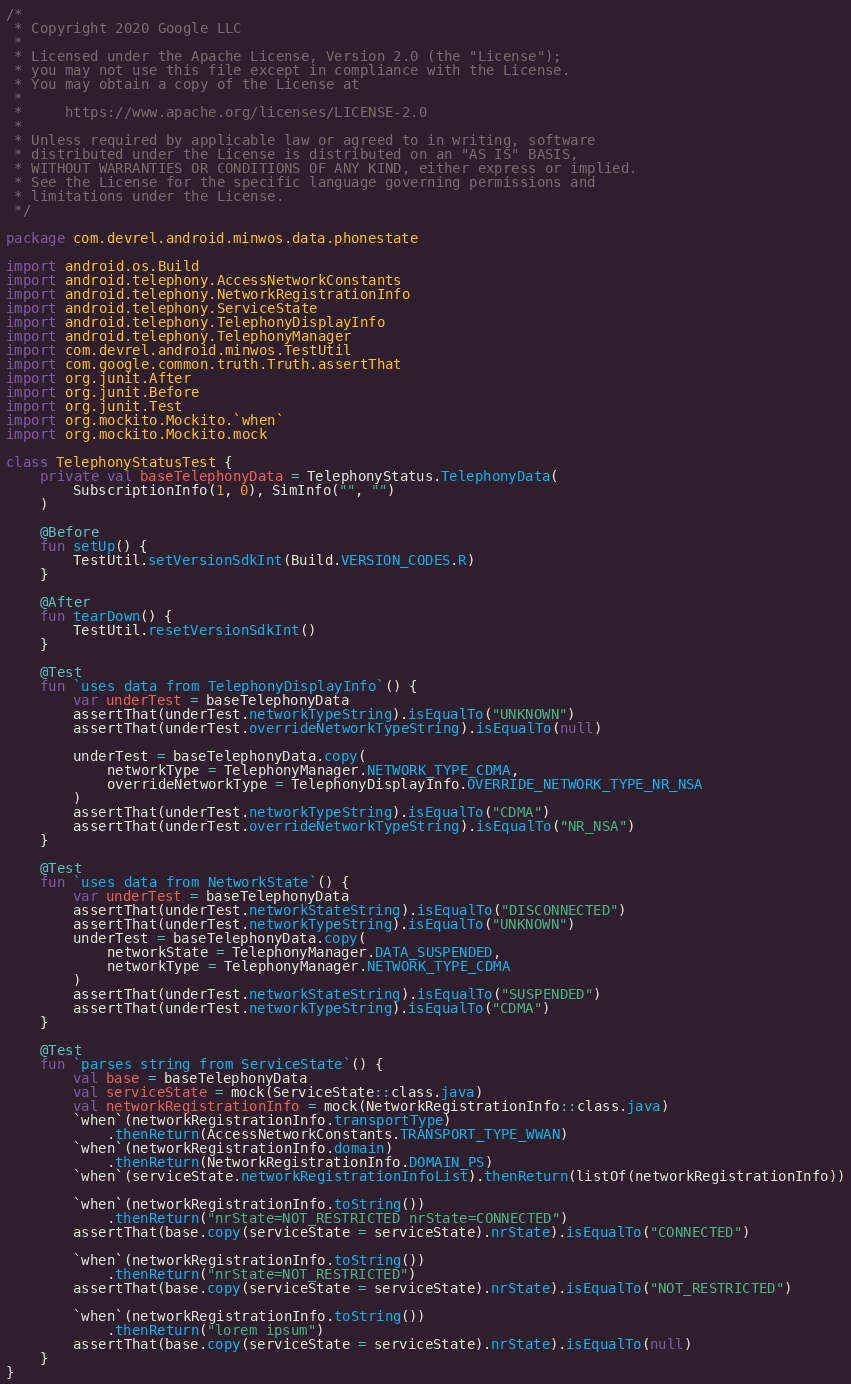<code> <loc_0><loc_0><loc_500><loc_500><_Kotlin_>/*
 * Copyright 2020 Google LLC
 *
 * Licensed under the Apache License, Version 2.0 (the "License");
 * you may not use this file except in compliance with the License.
 * You may obtain a copy of the License at
 *
 *     https://www.apache.org/licenses/LICENSE-2.0
 *
 * Unless required by applicable law or agreed to in writing, software
 * distributed under the License is distributed on an "AS IS" BASIS,
 * WITHOUT WARRANTIES OR CONDITIONS OF ANY KIND, either express or implied.
 * See the License for the specific language governing permissions and
 * limitations under the License.
 */

package com.devrel.android.minwos.data.phonestate

import android.os.Build
import android.telephony.AccessNetworkConstants
import android.telephony.NetworkRegistrationInfo
import android.telephony.ServiceState
import android.telephony.TelephonyDisplayInfo
import android.telephony.TelephonyManager
import com.devrel.android.minwos.TestUtil
import com.google.common.truth.Truth.assertThat
import org.junit.After
import org.junit.Before
import org.junit.Test
import org.mockito.Mockito.`when`
import org.mockito.Mockito.mock

class TelephonyStatusTest {
    private val baseTelephonyData = TelephonyStatus.TelephonyData(
        SubscriptionInfo(1, 0), SimInfo("", "")
    )

    @Before
    fun setUp() {
        TestUtil.setVersionSdkInt(Build.VERSION_CODES.R)
    }

    @After
    fun tearDown() {
        TestUtil.resetVersionSdkInt()
    }

    @Test
    fun `uses data from TelephonyDisplayInfo`() {
        var underTest = baseTelephonyData
        assertThat(underTest.networkTypeString).isEqualTo("UNKNOWN")
        assertThat(underTest.overrideNetworkTypeString).isEqualTo(null)

        underTest = baseTelephonyData.copy(
            networkType = TelephonyManager.NETWORK_TYPE_CDMA,
            overrideNetworkType = TelephonyDisplayInfo.OVERRIDE_NETWORK_TYPE_NR_NSA
        )
        assertThat(underTest.networkTypeString).isEqualTo("CDMA")
        assertThat(underTest.overrideNetworkTypeString).isEqualTo("NR_NSA")
    }

    @Test
    fun `uses data from NetworkState`() {
        var underTest = baseTelephonyData
        assertThat(underTest.networkStateString).isEqualTo("DISCONNECTED")
        assertThat(underTest.networkTypeString).isEqualTo("UNKNOWN")
        underTest = baseTelephonyData.copy(
            networkState = TelephonyManager.DATA_SUSPENDED,
            networkType = TelephonyManager.NETWORK_TYPE_CDMA
        )
        assertThat(underTest.networkStateString).isEqualTo("SUSPENDED")
        assertThat(underTest.networkTypeString).isEqualTo("CDMA")
    }

    @Test
    fun `parses string from ServiceState`() {
        val base = baseTelephonyData
        val serviceState = mock(ServiceState::class.java)
        val networkRegistrationInfo = mock(NetworkRegistrationInfo::class.java)
        `when`(networkRegistrationInfo.transportType)
            .thenReturn(AccessNetworkConstants.TRANSPORT_TYPE_WWAN)
        `when`(networkRegistrationInfo.domain)
            .thenReturn(NetworkRegistrationInfo.DOMAIN_PS)
        `when`(serviceState.networkRegistrationInfoList).thenReturn(listOf(networkRegistrationInfo))

        `when`(networkRegistrationInfo.toString())
            .thenReturn("nrState=NOT_RESTRICTED nrState=CONNECTED")
        assertThat(base.copy(serviceState = serviceState).nrState).isEqualTo("CONNECTED")

        `when`(networkRegistrationInfo.toString())
            .thenReturn("nrState=NOT_RESTRICTED")
        assertThat(base.copy(serviceState = serviceState).nrState).isEqualTo("NOT_RESTRICTED")

        `when`(networkRegistrationInfo.toString())
            .thenReturn("lorem ipsum")
        assertThat(base.copy(serviceState = serviceState).nrState).isEqualTo(null)
    }
}
</code> 